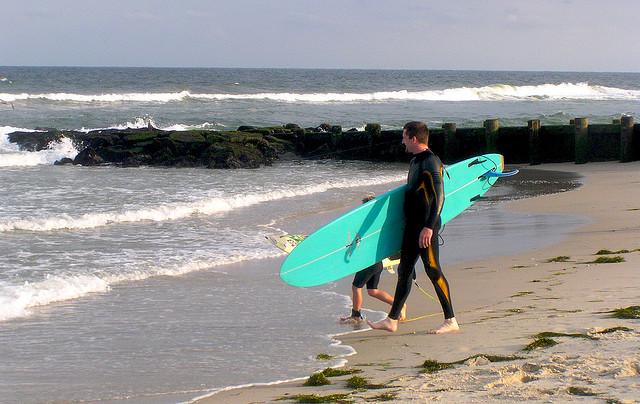What sport are these two engaging in?
Short answer required. Surfing. How many people are in this picture?
Write a very short answer. 2. What color is his surfboard?
Give a very brief answer. Teal. 